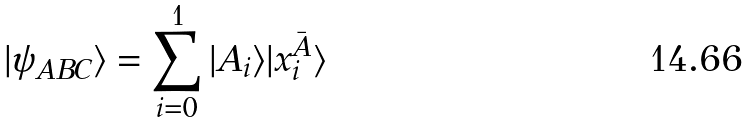<formula> <loc_0><loc_0><loc_500><loc_500>| \psi _ { A B C } \rangle = \sum _ { i = 0 } ^ { 1 } | A _ { i } \rangle | x _ { i } ^ { \bar { A } } \rangle</formula> 